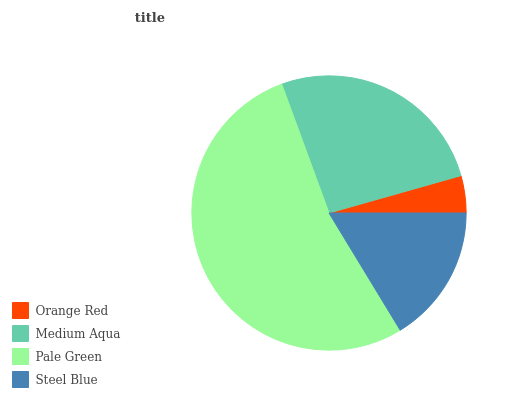Is Orange Red the minimum?
Answer yes or no. Yes. Is Pale Green the maximum?
Answer yes or no. Yes. Is Medium Aqua the minimum?
Answer yes or no. No. Is Medium Aqua the maximum?
Answer yes or no. No. Is Medium Aqua greater than Orange Red?
Answer yes or no. Yes. Is Orange Red less than Medium Aqua?
Answer yes or no. Yes. Is Orange Red greater than Medium Aqua?
Answer yes or no. No. Is Medium Aqua less than Orange Red?
Answer yes or no. No. Is Medium Aqua the high median?
Answer yes or no. Yes. Is Steel Blue the low median?
Answer yes or no. Yes. Is Orange Red the high median?
Answer yes or no. No. Is Medium Aqua the low median?
Answer yes or no. No. 